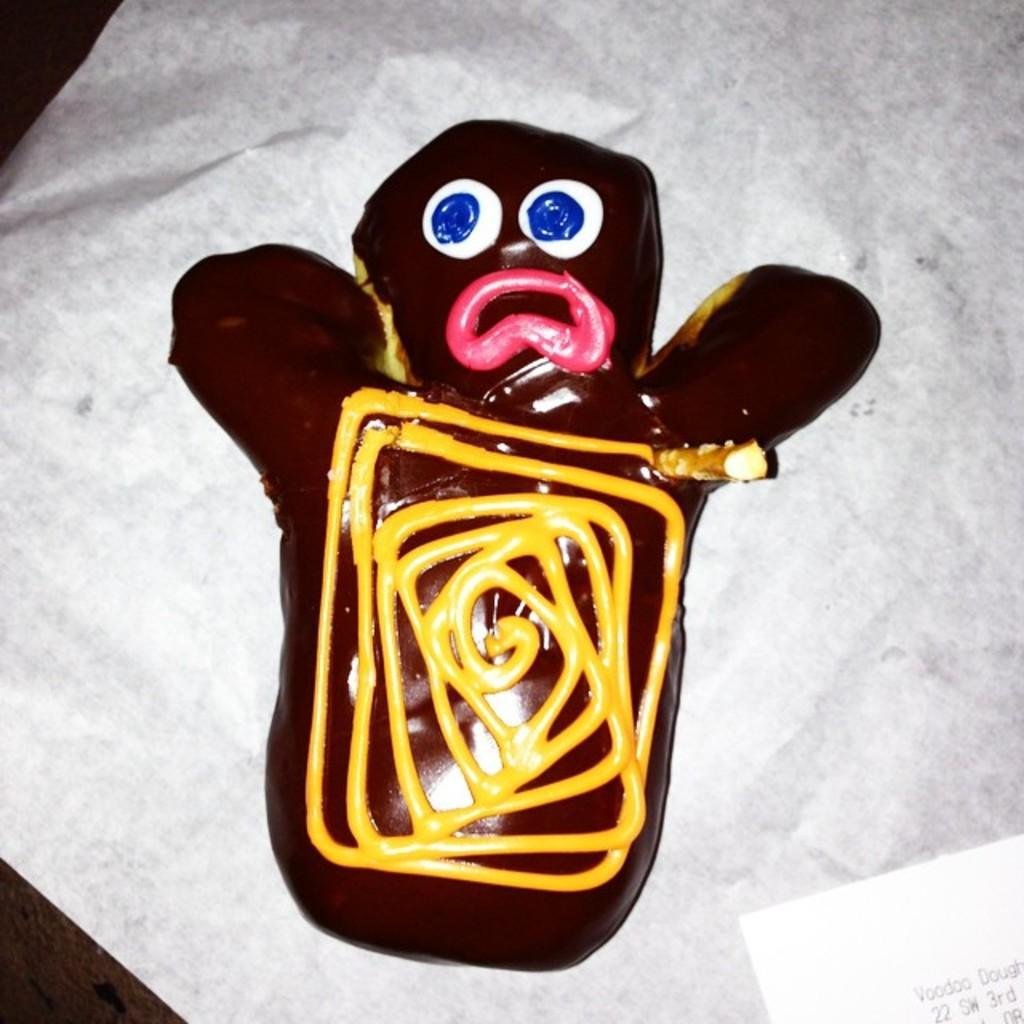What is the main subject in the center of the image? There is a cake in the center of the image. What else can be seen in the image besides the cake? There is a paper and a napkin in the image. Where are the cake, paper, and napkin located? The cake, paper, and napkin are placed on a table. What type of deer can be seen eating a berry in the image? There are no deer or berries present in the image; it features a cake, paper, and napkin on a table. 